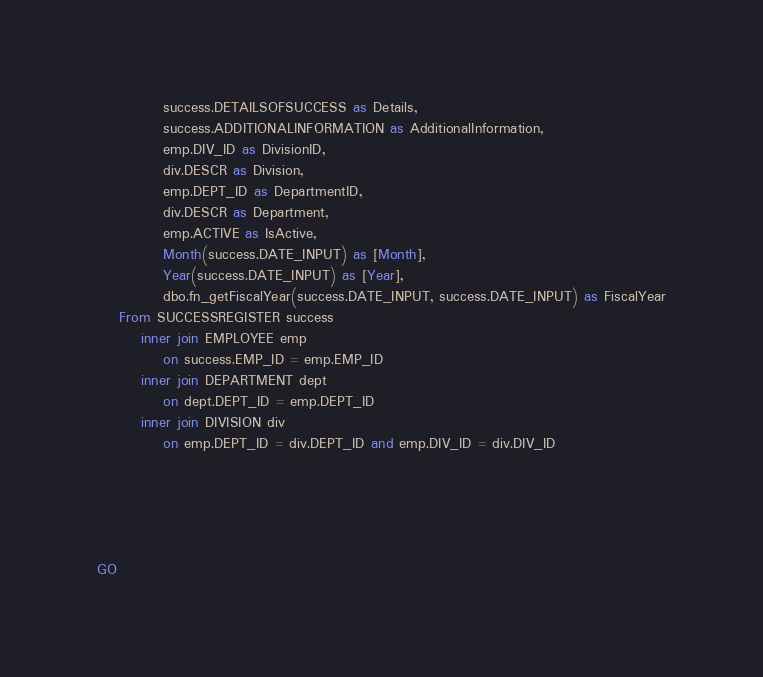Convert code to text. <code><loc_0><loc_0><loc_500><loc_500><_SQL_>			success.DETAILSOFSUCCESS as Details,
			success.ADDITIONALINFORMATION as AdditionalInformation,
			emp.DIV_ID as DivisionID,
			div.DESCR as Division,
			emp.DEPT_ID as DepartmentID,
			div.DESCR as Department,
			emp.ACTIVE as IsActive,
			Month(success.DATE_INPUT) as [Month],
			Year(success.DATE_INPUT) as [Year],
			dbo.fn_getFiscalYear(success.DATE_INPUT, success.DATE_INPUT) as FiscalYear
	From SUCCESSREGISTER success
		inner join EMPLOYEE emp 
			on success.EMP_ID = emp.EMP_ID
		inner join DEPARTMENT dept
			on dept.DEPT_ID = emp.DEPT_ID
		inner join DIVISION div
			on emp.DEPT_ID = div.DEPT_ID and emp.DIV_ID = div.DIV_ID





GO


</code> 